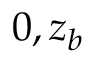<formula> <loc_0><loc_0><loc_500><loc_500>0 , z _ { b }</formula> 